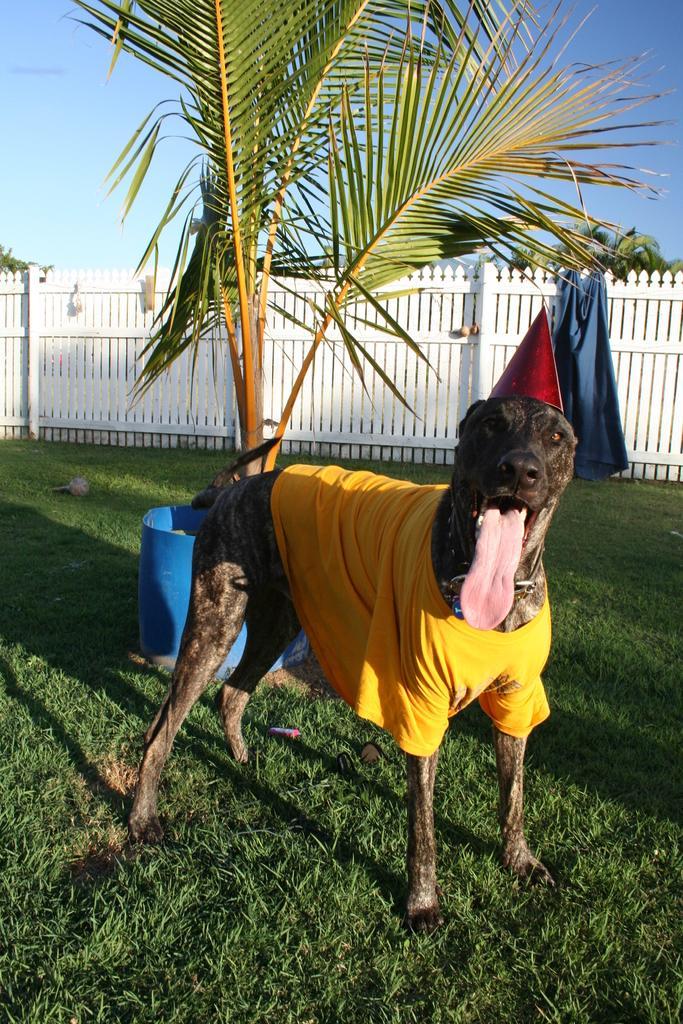Can you describe this image briefly? In this image we can see a dog with a cap, there are some trees, fence, clothes and some other objects on the ground, in the background we can see the sky. 